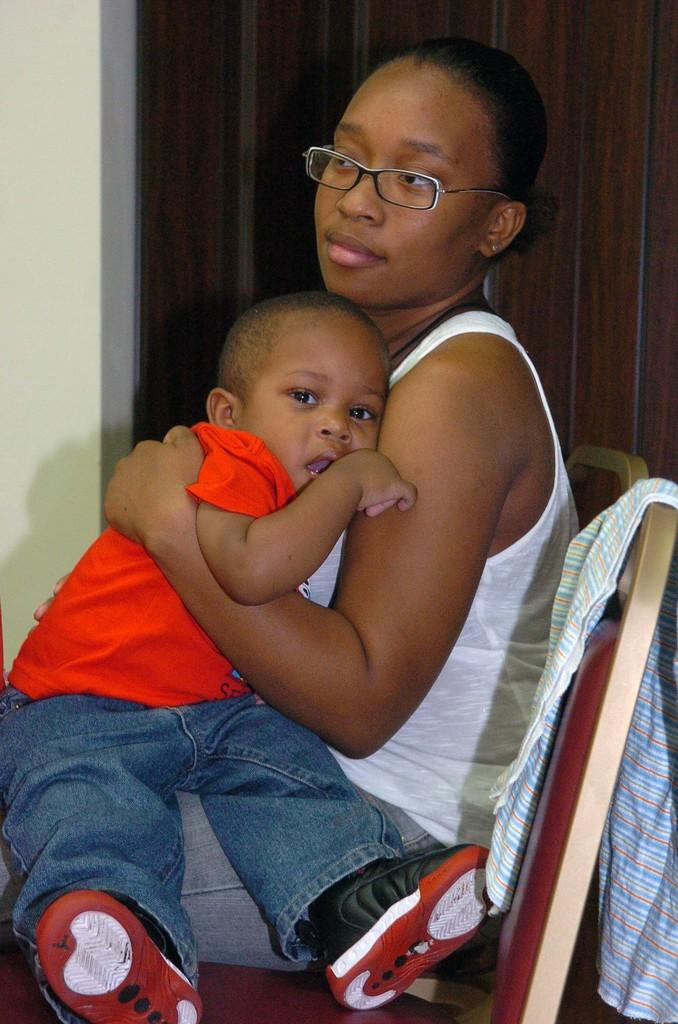Who is the main subject in the foreground of the image? There is a lady in the foreground of the image. What is the lady doing in the image? A small boy is on the lady's lap. What can be seen on the right side of the image? There is a cloth on the right side of the image. What architectural feature is visible in the background of the image? There appears to be a door in the background of the image. What type of power source is visible in the image? There is no power source visible in the image. What kind of work is the lady performing in the image? The lady is not performing any work in the image; she is holding a small boy on her lap. 